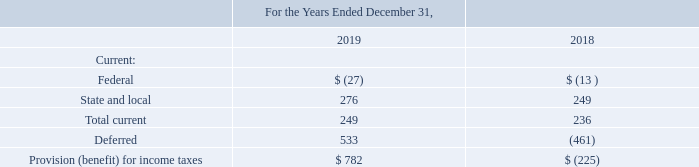Note 10 – Income taxes
The provision (benefit) for income taxes consists of the following:
What is the provision (benefit) for total current income taxes for 2018 and 2019 respectively? 236, 249. What is the deferred provision (benefit) for income tax for 2018 and 2019 respectively? (461), 533. What is the total provision (benefit) for income taxes in 2019? 782. What is the change in provision (benefit) for state and local income taxes between 2018 and 2019? 276-249
Answer: 27. What is the average total current provision (benefit) for income taxes for 2018 and 2019? (236+249)/2
Answer: 242.5. What is the percentage change in provisions (benefit) for state and local income taxes between 2018 and 2019?
Answer scale should be: percent. (276-249)/249
Answer: 10.84. 